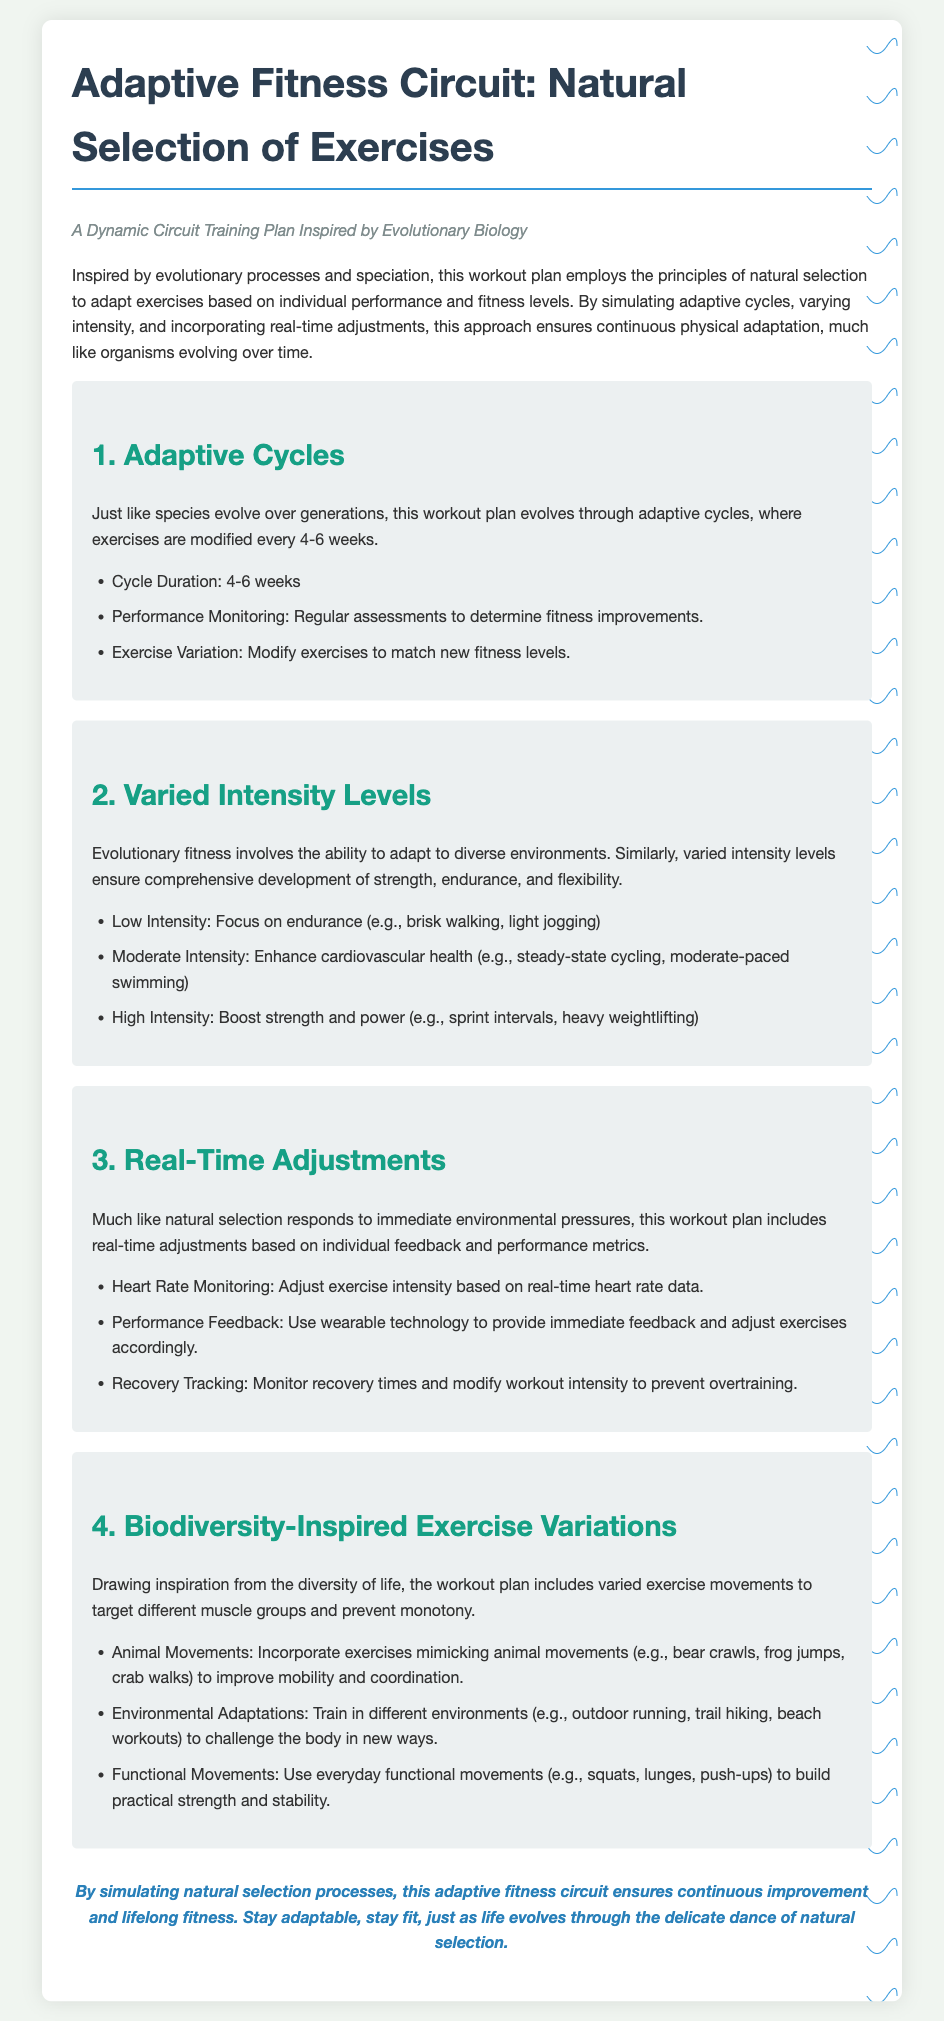What is the workout plan inspired by? The workout plan is inspired by evolutionary processes and speciation.
Answer: evolutionary processes and speciation How often are exercises modified in the adaptive cycles? Exercises are modified every 4-6 weeks during adaptive cycles.
Answer: 4-6 weeks What type of intensity focuses on endurance? The low intensity category focuses on endurance.
Answer: low intensity What technology is used for performance feedback? Wearable technology is used to provide immediate feedback.
Answer: wearable technology What movement type mimics animal movements? Exercises like bear crawls mimic animal movements.
Answer: bear crawls What is monitored to adjust exercise intensity in real-time? Heart rate is monitored to adjust exercise intensity.
Answer: Heart rate Which fitness aspect is enhanced by moderate intensity? Cardiovascular health is enhanced by moderate intensity.
Answer: cardiovascular health What does biodiversity-inspired exercise variations aim to prevent? It aims to prevent monotony in workouts.
Answer: monotony What category includes exercises like squats and lunges? Functional movements include exercises like squats and lunges.
Answer: Functional movements 